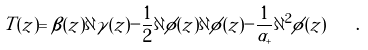<formula> <loc_0><loc_0><loc_500><loc_500>T ( z ) = \beta ( z ) \partial \gamma ( z ) - \frac { 1 } { 2 } \partial \phi ( z ) \partial \phi ( z ) - \frac { 1 } { \alpha _ { + } } \partial ^ { 2 } \phi ( z ) \quad .</formula> 